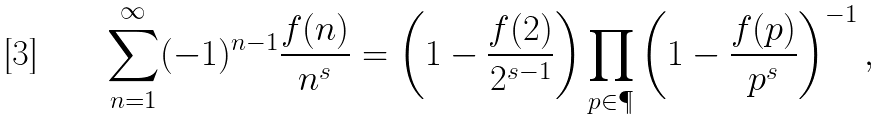Convert formula to latex. <formula><loc_0><loc_0><loc_500><loc_500>\sum _ { n = 1 } ^ { \infty } ( - 1 ) ^ { n - 1 } \frac { f ( n ) } { n ^ { s } } = \left ( 1 - \frac { f ( 2 ) } { 2 ^ { s - 1 } } \right ) \prod _ { p \in \P } \left ( 1 - \frac { f ( p ) } { p ^ { s } } \right ) ^ { - 1 } ,</formula> 